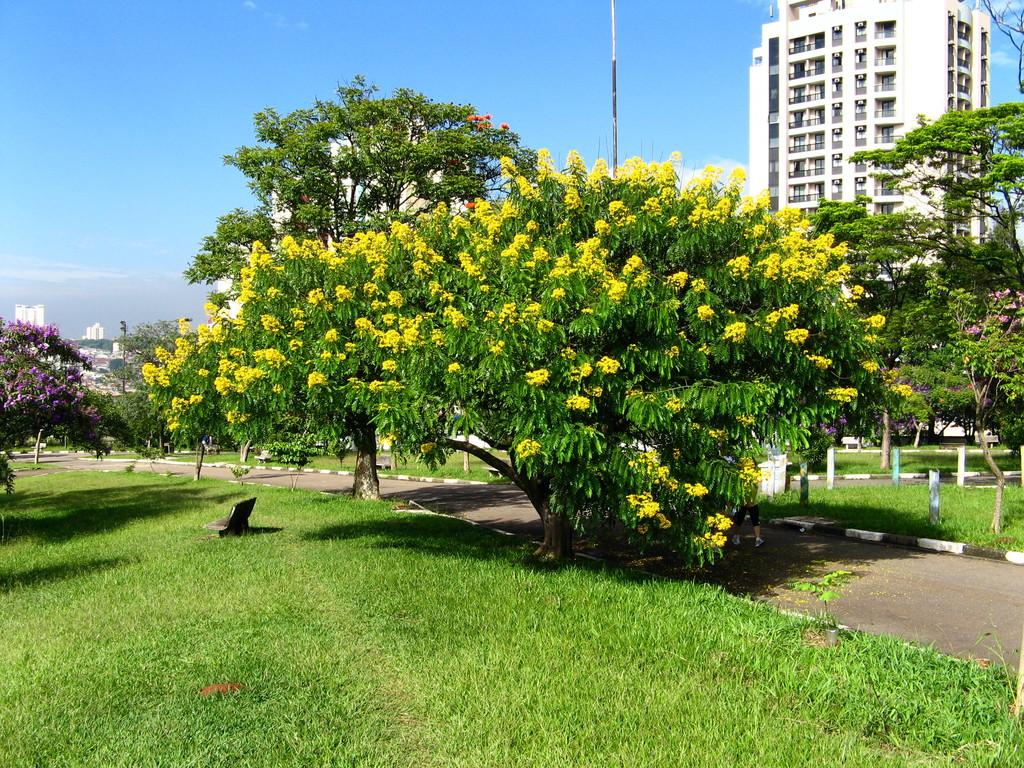What type of vegetation can be seen in the image? There are flowers, trees, and grass in the image. What type of man-made structures are present in the image? There are buildings and poles in the image. What is the condition of the sky in the image? The sky is visible in the image, and there are clouds present. What can be seen on the ground in the image? There is a road in the image. Are there any people in the image? Yes, there are people in the image. What type of hat is the home wearing in the image? There is no home or hat present in the image. What is the relation between the flowers and the clouds in the image? The image does not depict a relationship between the flowers and the clouds; they are separate elements in the scene. 